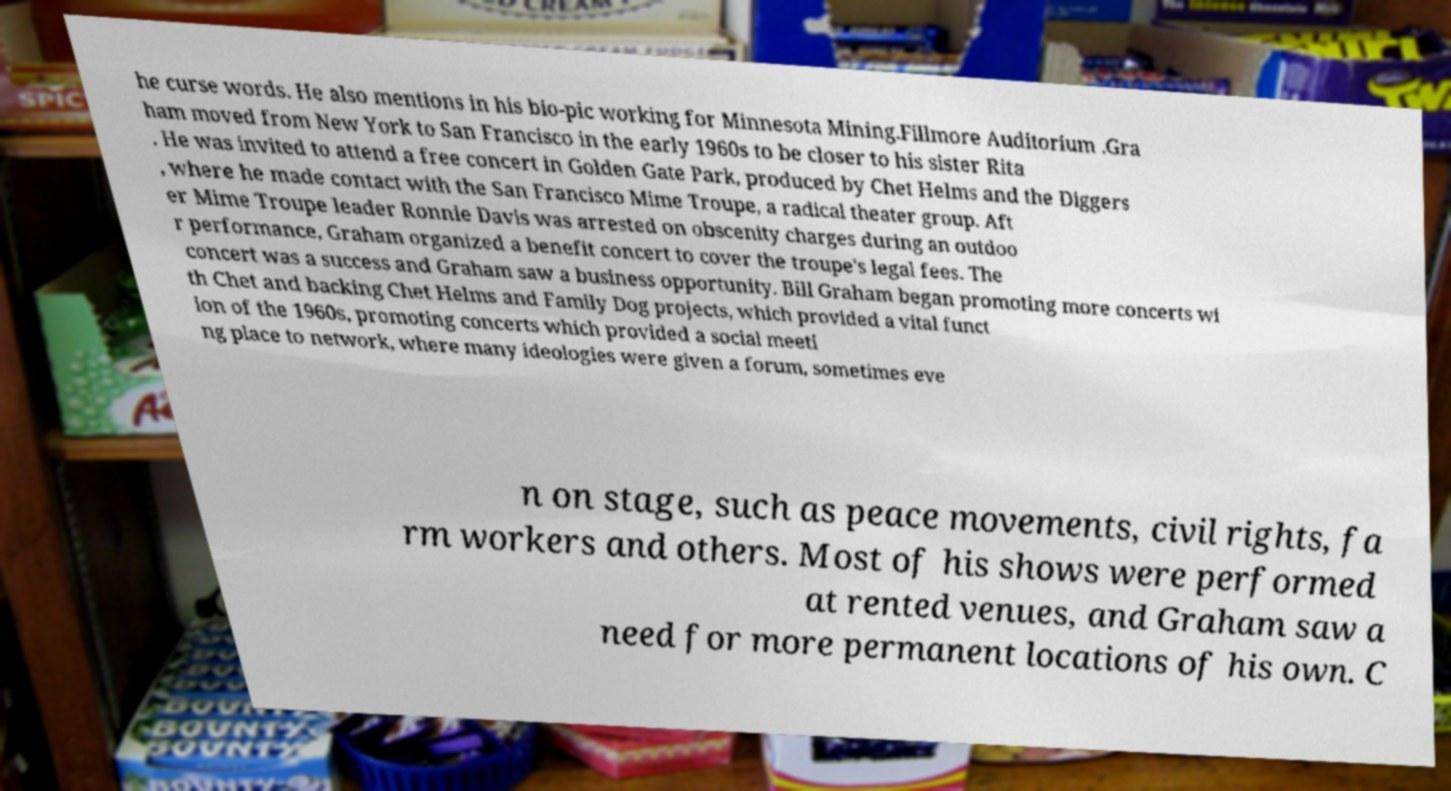I need the written content from this picture converted into text. Can you do that? he curse words. He also mentions in his bio-pic working for Minnesota Mining.Fillmore Auditorium .Gra ham moved from New York to San Francisco in the early 1960s to be closer to his sister Rita . He was invited to attend a free concert in Golden Gate Park, produced by Chet Helms and the Diggers , where he made contact with the San Francisco Mime Troupe, a radical theater group. Aft er Mime Troupe leader Ronnie Davis was arrested on obscenity charges during an outdoo r performance, Graham organized a benefit concert to cover the troupe's legal fees. The concert was a success and Graham saw a business opportunity. Bill Graham began promoting more concerts wi th Chet and backing Chet Helms and Family Dog projects, which provided a vital funct ion of the 1960s, promoting concerts which provided a social meeti ng place to network, where many ideologies were given a forum, sometimes eve n on stage, such as peace movements, civil rights, fa rm workers and others. Most of his shows were performed at rented venues, and Graham saw a need for more permanent locations of his own. C 